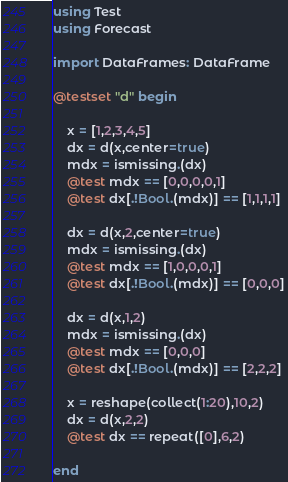<code> <loc_0><loc_0><loc_500><loc_500><_Julia_>using Test
using Forecast

import DataFrames: DataFrame

@testset "d" begin

    x = [1,2,3,4,5]
    dx = d(x,center=true)
    mdx = ismissing.(dx)
    @test mdx == [0,0,0,0,1]
    @test dx[.!Bool.(mdx)] == [1,1,1,1]

    dx = d(x,2,center=true)
    mdx = ismissing.(dx)
    @test mdx == [1,0,0,0,1]
    @test dx[.!Bool.(mdx)] == [0,0,0]

    dx = d(x,1,2)
    mdx = ismissing.(dx)
    @test mdx == [0,0,0]
    @test dx[.!Bool.(mdx)] == [2,2,2]

    x = reshape(collect(1:20),10,2)
    dx = d(x,2,2)
    @test dx == repeat([0],6,2)

end
</code> 